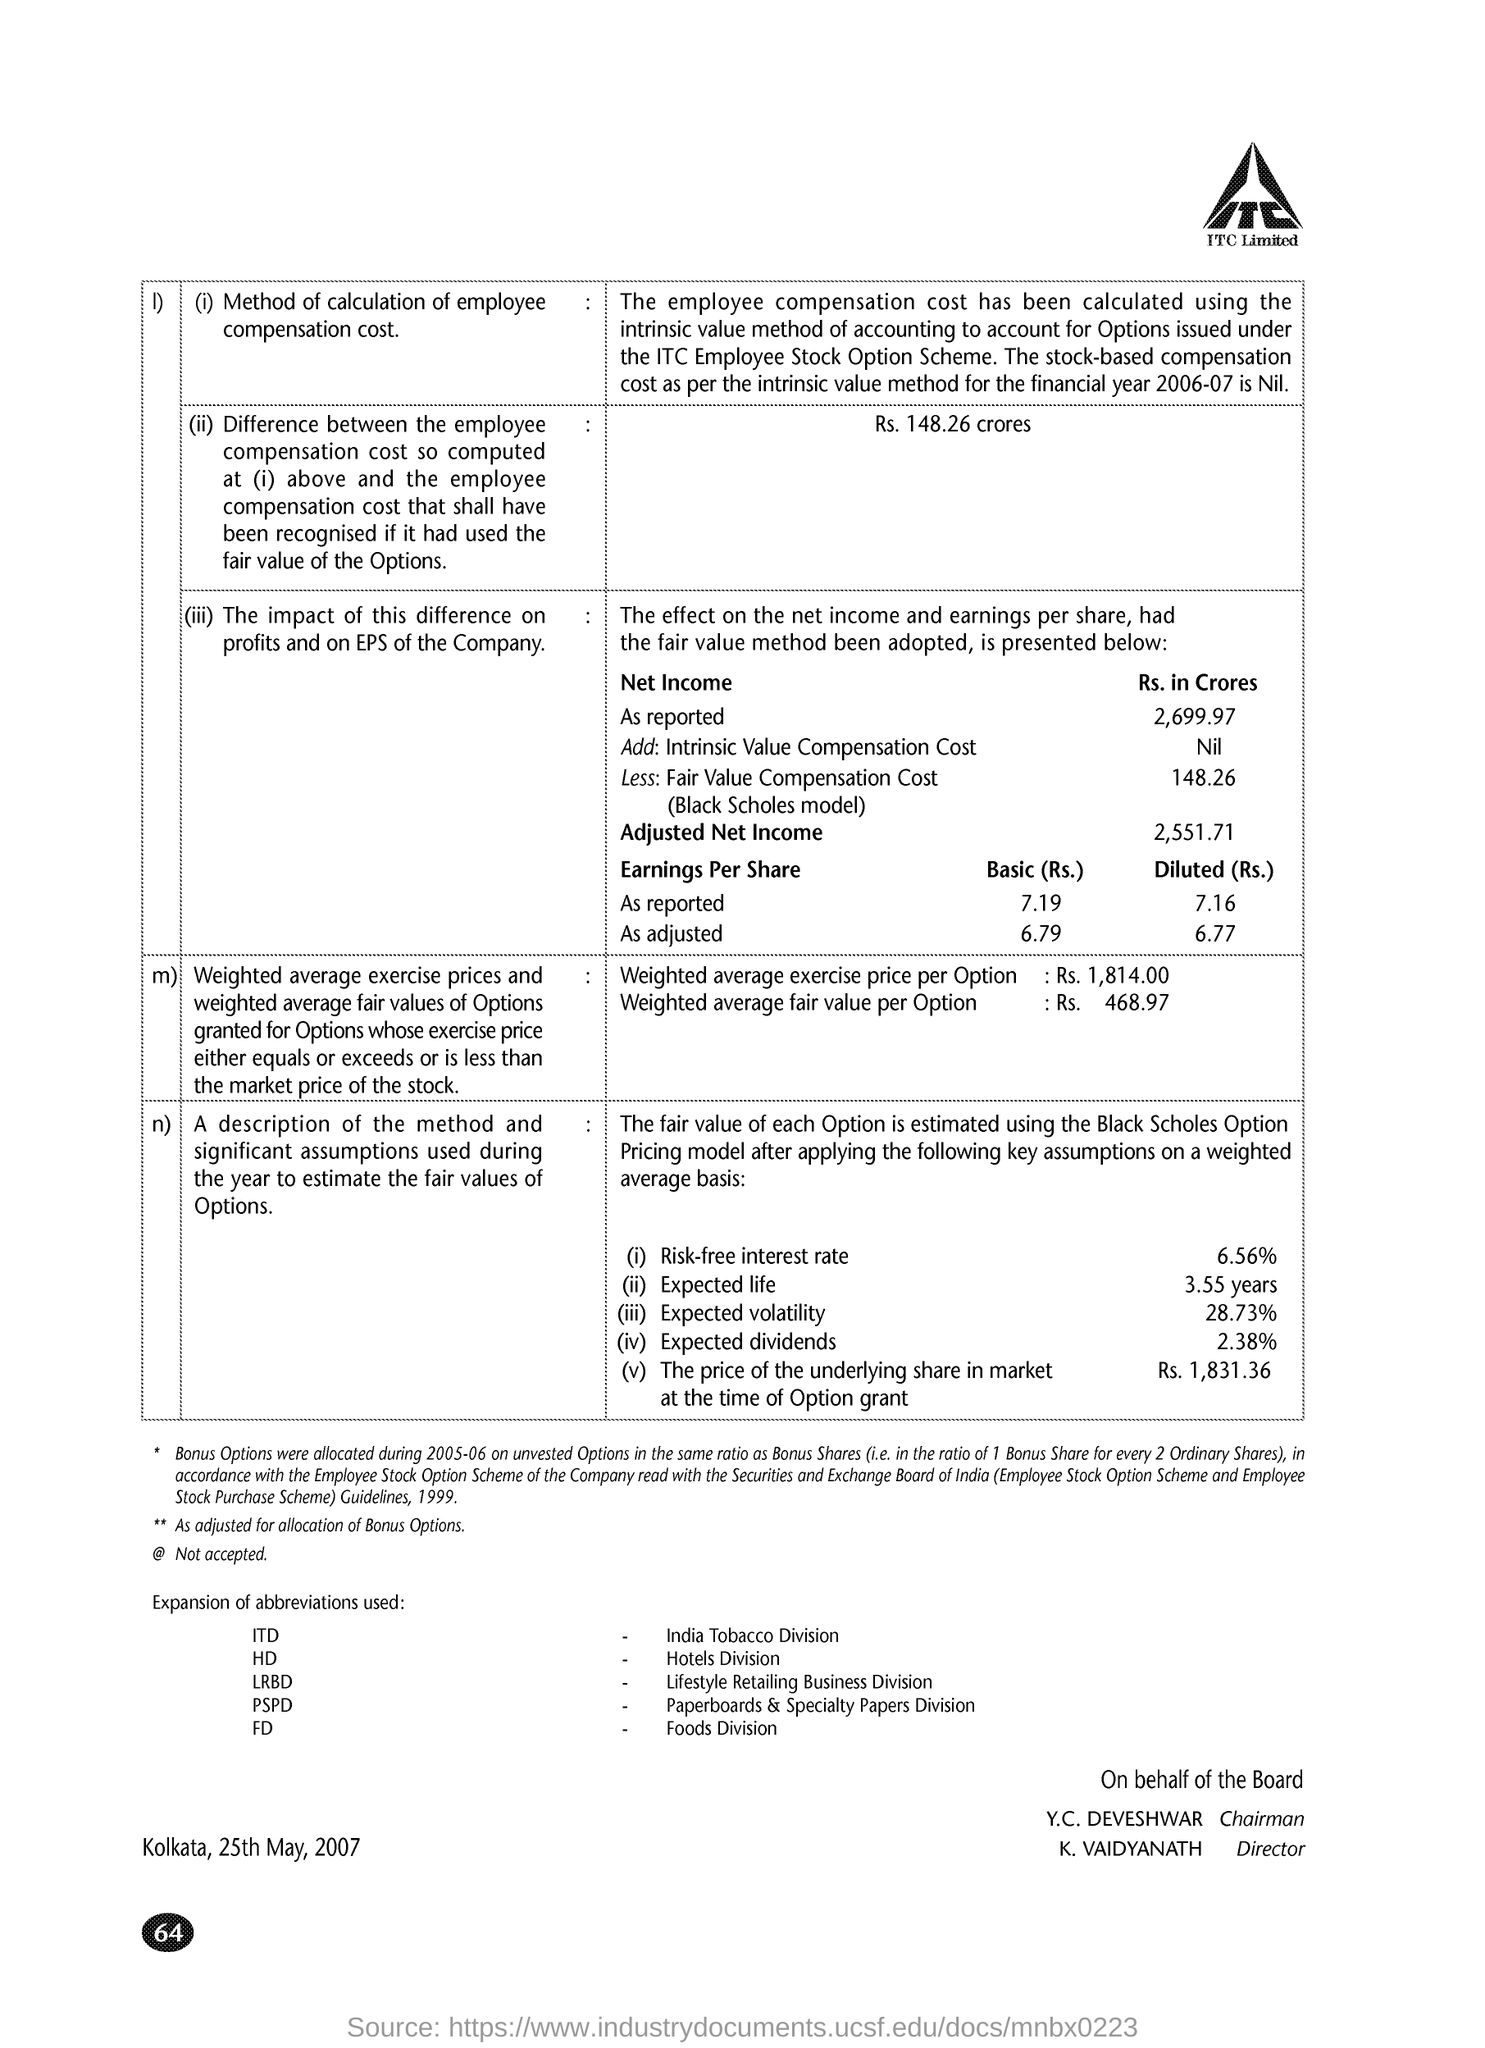Give some essential details in this illustration. LRBD stands for "Lifestyle Retailing Business Division," which is a term used to describe a specific type of business division that focuses on retailing products and services related to a particular lifestyle. The underlying share's price at the time of the option grant was Rs. 1,831.36. The full form of ITD is India Tobacco Division. The weighted average fair value per option is Rs. 468.97. The weighted average exercise price per Option is Rs. 1,814.00. 